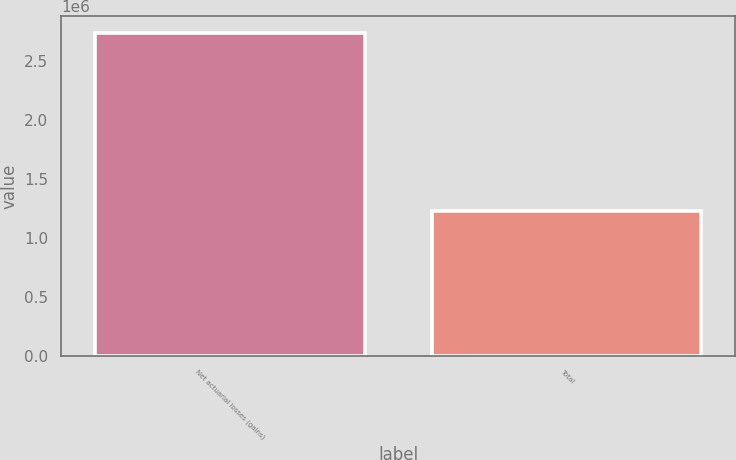Convert chart. <chart><loc_0><loc_0><loc_500><loc_500><bar_chart><fcel>Net actuarial losses (gains)<fcel>Total<nl><fcel>2.741e+06<fcel>1.23e+06<nl></chart> 